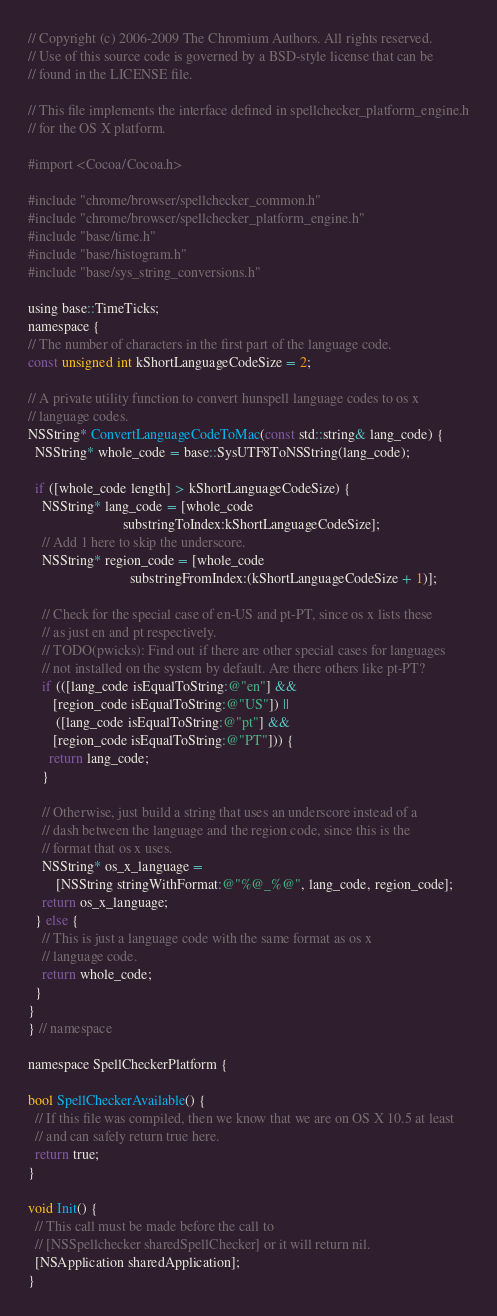<code> <loc_0><loc_0><loc_500><loc_500><_ObjectiveC_>// Copyright (c) 2006-2009 The Chromium Authors. All rights reserved.
// Use of this source code is governed by a BSD-style license that can be
// found in the LICENSE file.

// This file implements the interface defined in spellchecker_platform_engine.h
// for the OS X platform.

#import <Cocoa/Cocoa.h>

#include "chrome/browser/spellchecker_common.h"
#include "chrome/browser/spellchecker_platform_engine.h"
#include "base/time.h"
#include "base/histogram.h"
#include "base/sys_string_conversions.h"

using base::TimeTicks;
namespace {
// The number of characters in the first part of the language code.
const unsigned int kShortLanguageCodeSize = 2;

// A private utility function to convert hunspell language codes to os x
// language codes.
NSString* ConvertLanguageCodeToMac(const std::string& lang_code) {
  NSString* whole_code = base::SysUTF8ToNSString(lang_code);

  if ([whole_code length] > kShortLanguageCodeSize) {
    NSString* lang_code = [whole_code
                           substringToIndex:kShortLanguageCodeSize];
    // Add 1 here to skip the underscore.
    NSString* region_code = [whole_code
                             substringFromIndex:(kShortLanguageCodeSize + 1)];

    // Check for the special case of en-US and pt-PT, since os x lists these
    // as just en and pt respectively.
    // TODO(pwicks): Find out if there are other special cases for languages
    // not installed on the system by default. Are there others like pt-PT?
    if (([lang_code isEqualToString:@"en"] &&
       [region_code isEqualToString:@"US"]) ||
        ([lang_code isEqualToString:@"pt"] &&
       [region_code isEqualToString:@"PT"])) {
      return lang_code;
    }

    // Otherwise, just build a string that uses an underscore instead of a
    // dash between the language and the region code, since this is the
    // format that os x uses.
    NSString* os_x_language =
        [NSString stringWithFormat:@"%@_%@", lang_code, region_code];
    return os_x_language;
  } else {
    // This is just a language code with the same format as os x
    // language code.
    return whole_code;
  }
}
} // namespace

namespace SpellCheckerPlatform {

bool SpellCheckerAvailable() {
  // If this file was compiled, then we know that we are on OS X 10.5 at least
  // and can safely return true here.
  return true;
}

void Init() {
  // This call must be made before the call to
  // [NSSpellchecker sharedSpellChecker] or it will return nil.
  [NSApplication sharedApplication];
}
</code> 